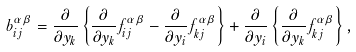<formula> <loc_0><loc_0><loc_500><loc_500>b _ { i j } ^ { \alpha \beta } = \frac { \partial } { \partial y _ { k } } \left \{ \frac { \partial } { \partial y _ { k } } f _ { i j } ^ { \alpha \beta } - \frac { \partial } { \partial y _ { i } } f _ { k j } ^ { \alpha \beta } \right \} + \frac { \partial } { \partial y _ { i } } \left \{ \frac { \partial } { \partial y _ { k } } f _ { k j } ^ { \alpha \beta } \right \} ,</formula> 